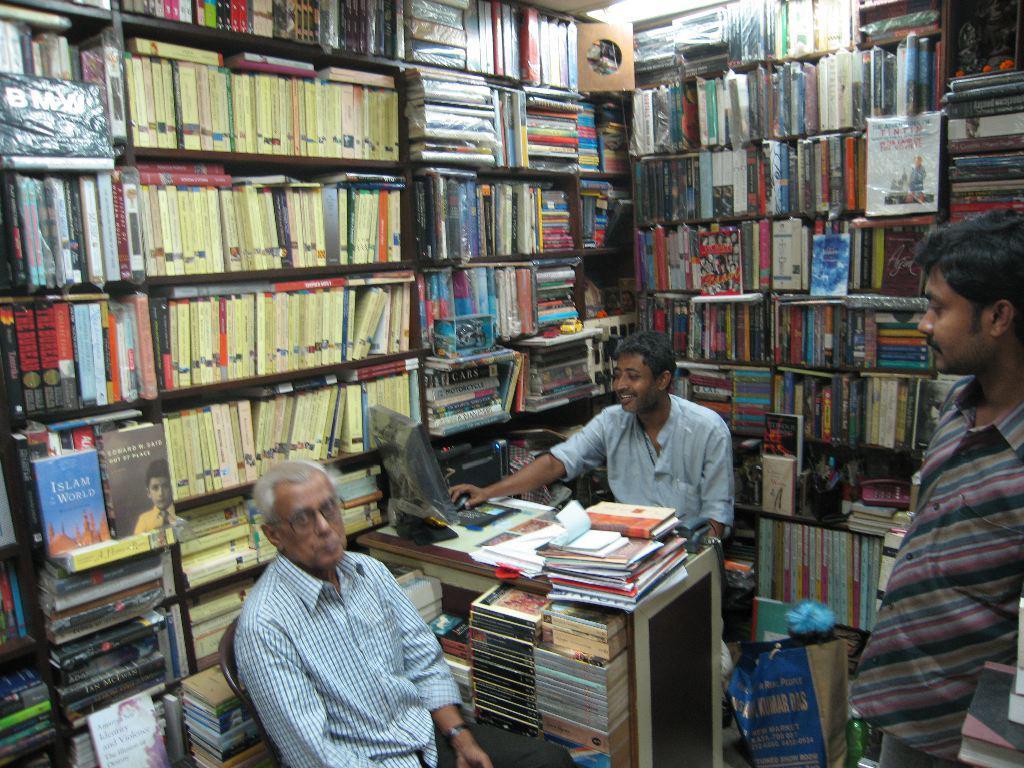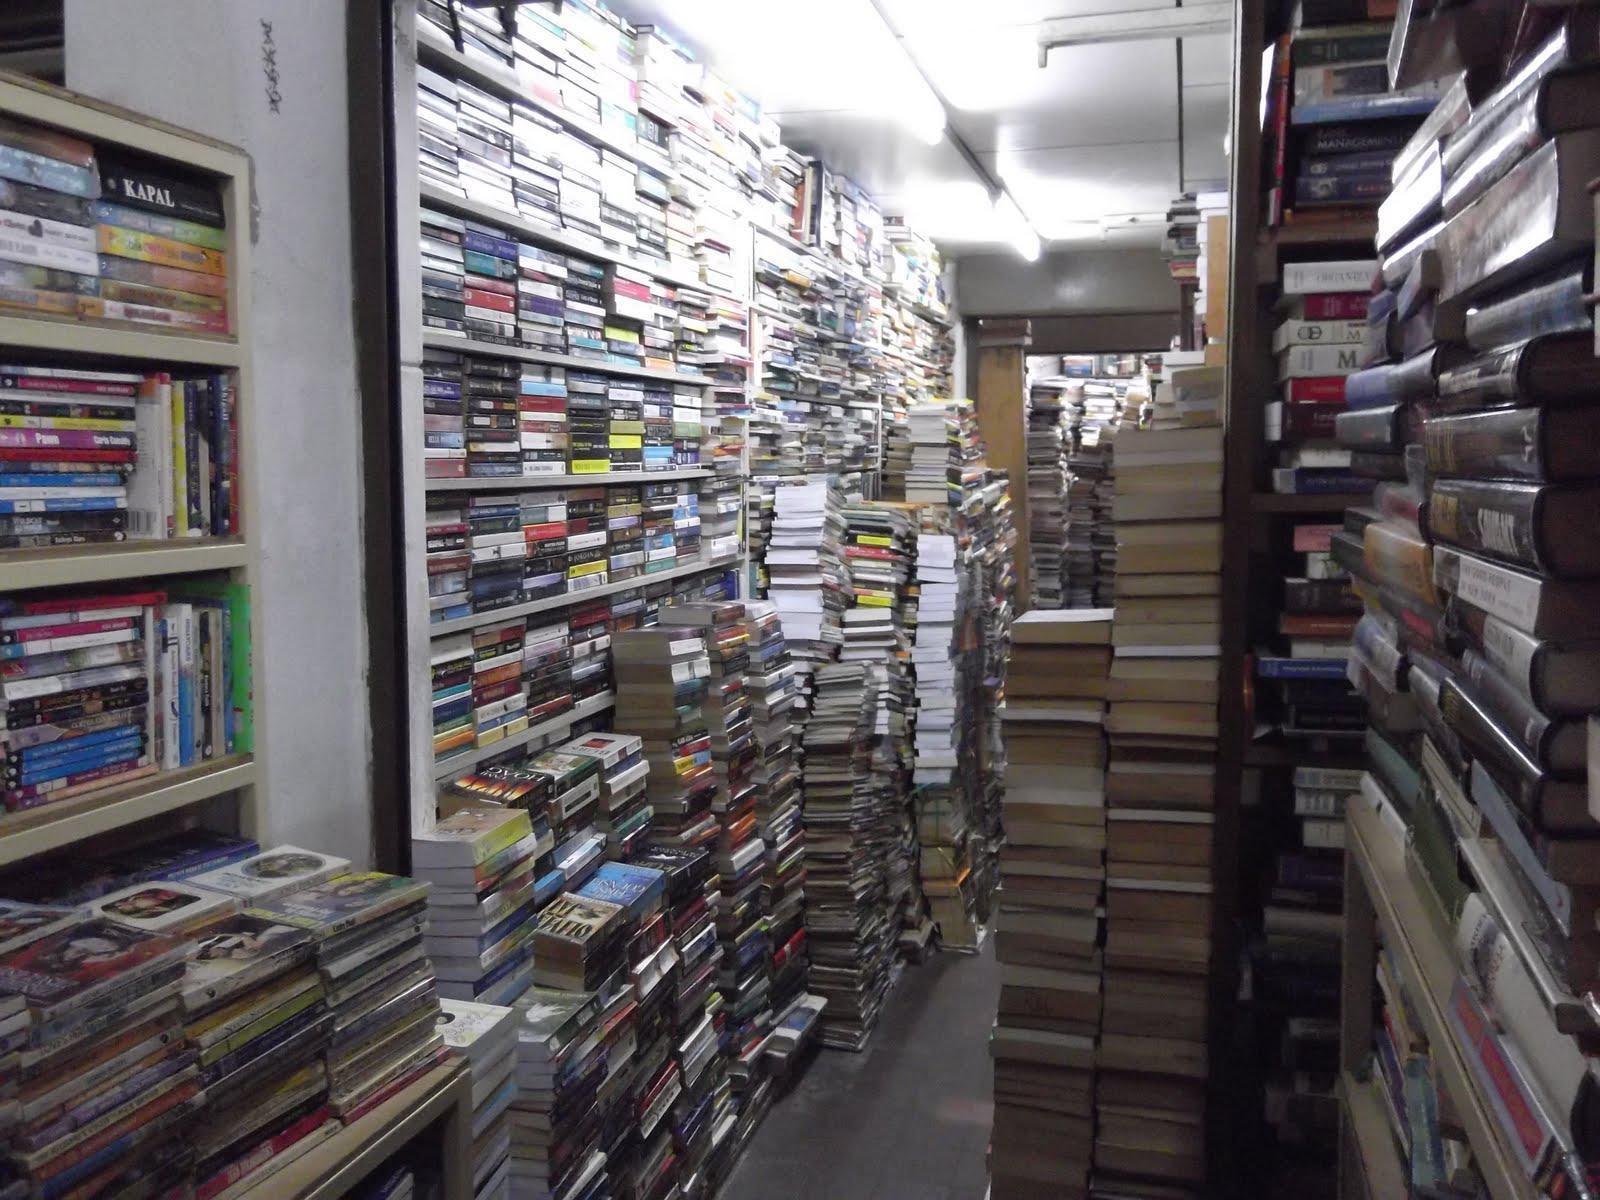The first image is the image on the left, the second image is the image on the right. Considering the images on both sides, is "There is a person behind the counter of a bookstore that has at least four separate bookshelves." valid? Answer yes or no. Yes. 